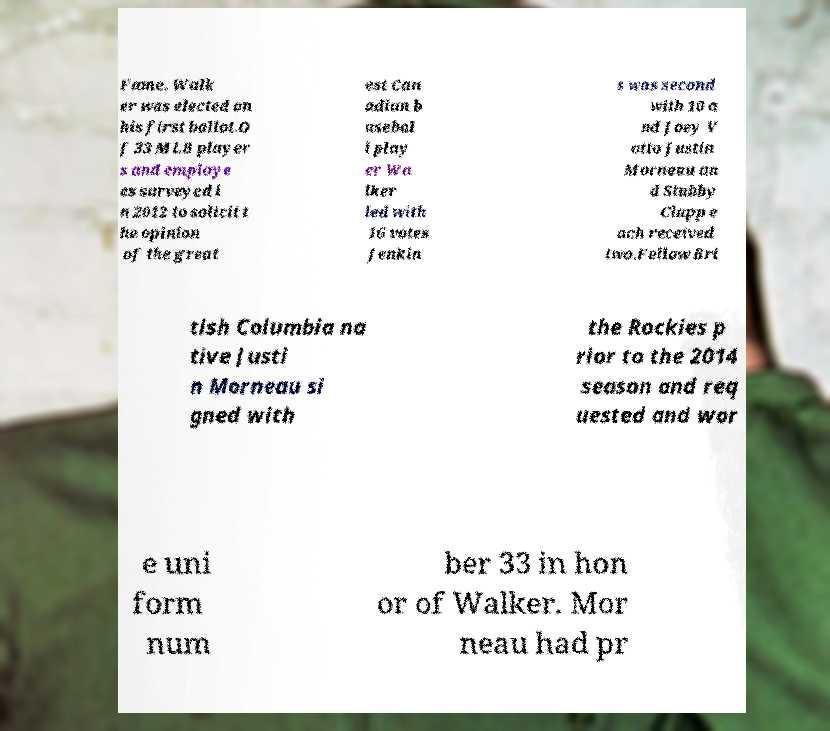There's text embedded in this image that I need extracted. Can you transcribe it verbatim? Fame. Walk er was elected on his first ballot.O f 33 MLB player s and employe es surveyed i n 2012 to solicit t he opinion of the great est Can adian b asebal l play er Wa lker led with 16 votes Jenkin s was second with 10 a nd Joey V otto Justin Morneau an d Stubby Clapp e ach received two.Fellow Bri tish Columbia na tive Justi n Morneau si gned with the Rockies p rior to the 2014 season and req uested and wor e uni form num ber 33 in hon or of Walker. Mor neau had pr 